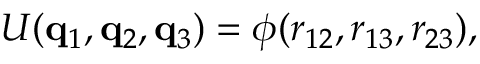<formula> <loc_0><loc_0><loc_500><loc_500>U ( q _ { 1 } , q _ { 2 } , q _ { 3 } ) = \phi ( r _ { 1 2 } , r _ { 1 3 } , r _ { 2 3 } ) ,</formula> 